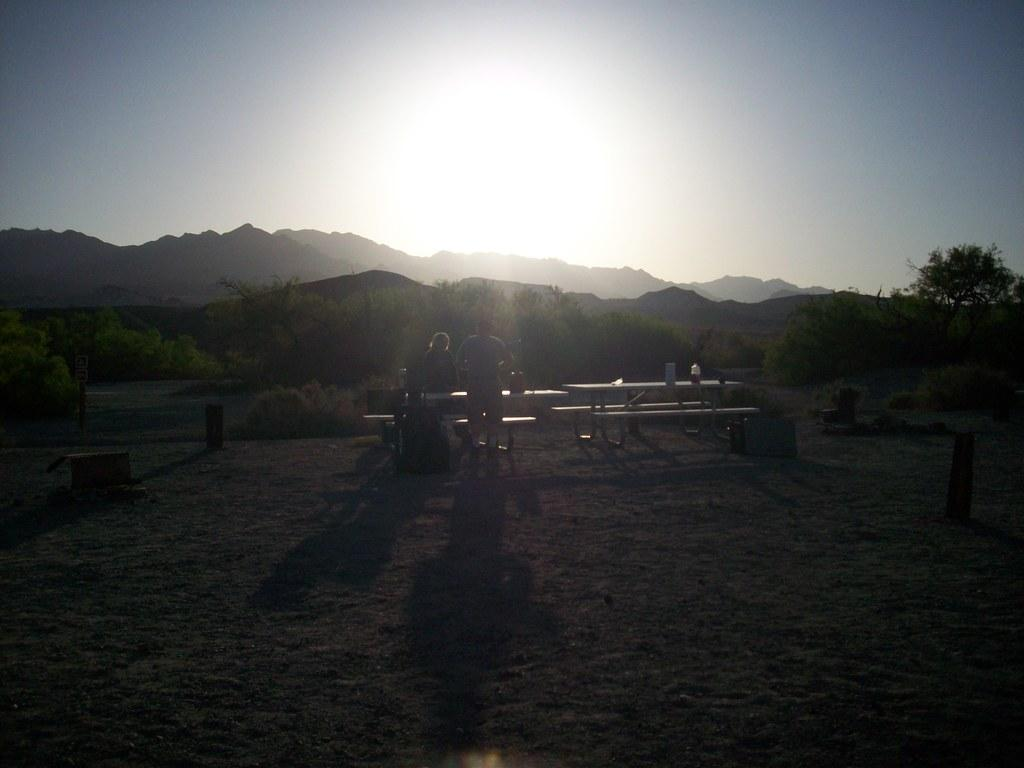What type of seating is present in the image? There are benches in the image. How many people can be seen in the image? There are two people in the image. What type of vegetation is present in the image? There are trees in the image. What can be seen in the distance in the image? There are hills visible in the background of the image. What is visible in the sky in the image? There are clouds in the sky in the image. Can you tell me how many thumbs the people in the image are using to swim? There is no swimming or thumbs visible in the image; the people are sitting on benches. 